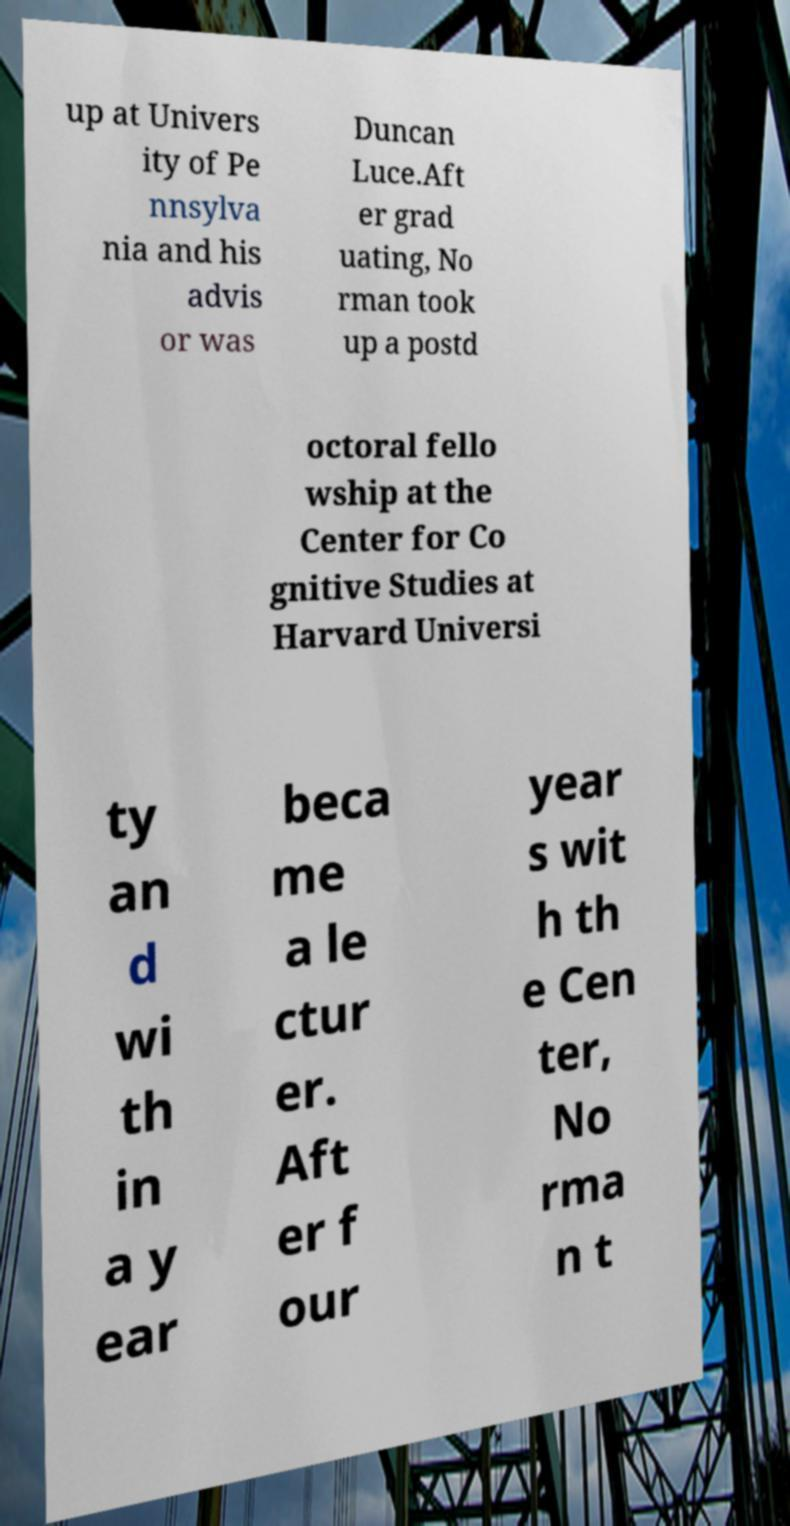Please identify and transcribe the text found in this image. up at Univers ity of Pe nnsylva nia and his advis or was Duncan Luce.Aft er grad uating, No rman took up a postd octoral fello wship at the Center for Co gnitive Studies at Harvard Universi ty an d wi th in a y ear beca me a le ctur er. Aft er f our year s wit h th e Cen ter, No rma n t 